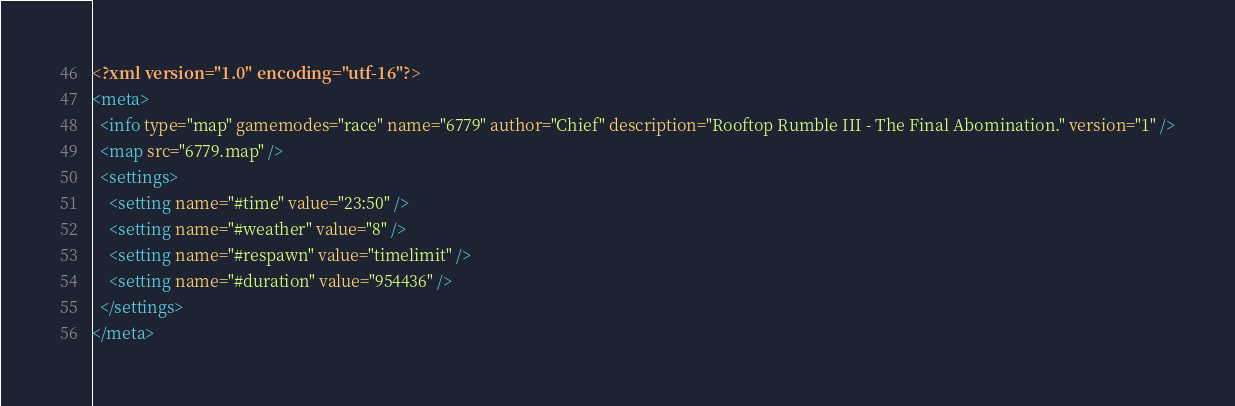<code> <loc_0><loc_0><loc_500><loc_500><_XML_><?xml version="1.0" encoding="utf-16"?>
<meta>
  <info type="map" gamemodes="race" name="6779" author="Chief" description="Rooftop Rumble III - The Final Abomination." version="1" />
  <map src="6779.map" />
  <settings>
    <setting name="#time" value="23:50" />
    <setting name="#weather" value="8" />
    <setting name="#respawn" value="timelimit" />
    <setting name="#duration" value="954436" />
  </settings>
</meta></code> 